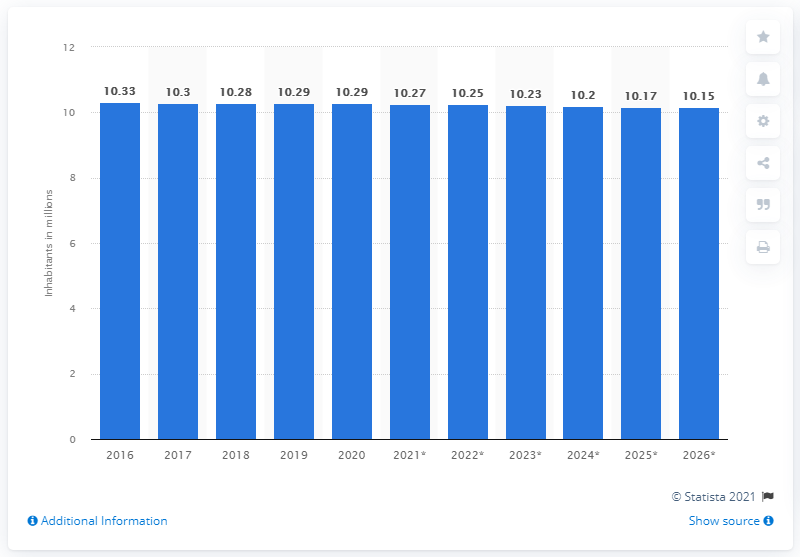Specify some key components in this picture. In 2020, the population of Portugal reached 10.29 million. In 2020, the population of Portugal was 10.2 million. According to data from 2020, the population of Portugal reached 10.29 million inhabitants. 